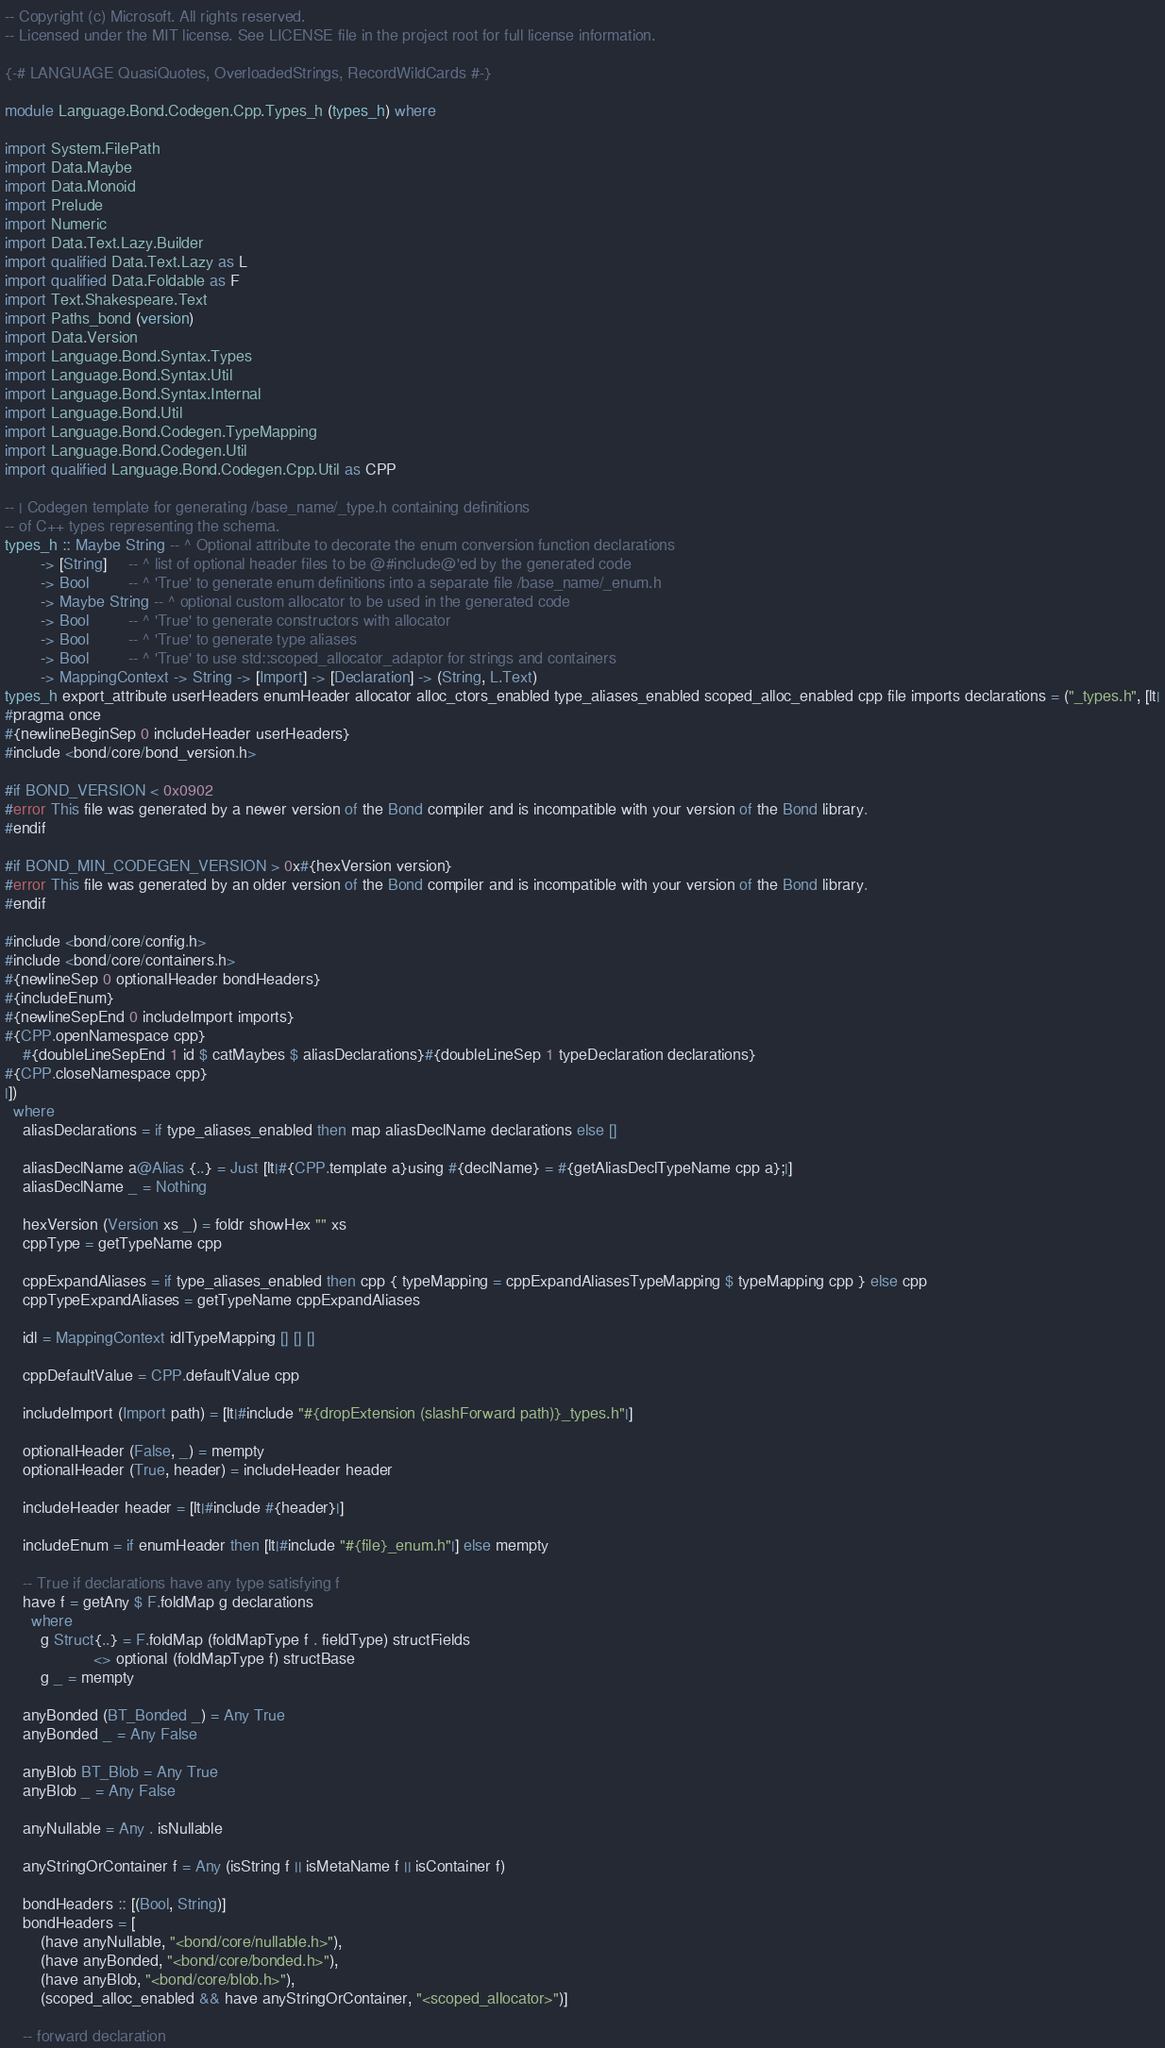Convert code to text. <code><loc_0><loc_0><loc_500><loc_500><_Haskell_>-- Copyright (c) Microsoft. All rights reserved.
-- Licensed under the MIT license. See LICENSE file in the project root for full license information.

{-# LANGUAGE QuasiQuotes, OverloadedStrings, RecordWildCards #-}

module Language.Bond.Codegen.Cpp.Types_h (types_h) where

import System.FilePath
import Data.Maybe
import Data.Monoid
import Prelude
import Numeric
import Data.Text.Lazy.Builder
import qualified Data.Text.Lazy as L
import qualified Data.Foldable as F
import Text.Shakespeare.Text
import Paths_bond (version)
import Data.Version
import Language.Bond.Syntax.Types
import Language.Bond.Syntax.Util
import Language.Bond.Syntax.Internal
import Language.Bond.Util
import Language.Bond.Codegen.TypeMapping
import Language.Bond.Codegen.Util
import qualified Language.Bond.Codegen.Cpp.Util as CPP

-- | Codegen template for generating /base_name/_type.h containing definitions
-- of C++ types representing the schema.
types_h :: Maybe String -- ^ Optional attribute to decorate the enum conversion function declarations
        -> [String]     -- ^ list of optional header files to be @#include@'ed by the generated code
        -> Bool         -- ^ 'True' to generate enum definitions into a separate file /base_name/_enum.h
        -> Maybe String -- ^ optional custom allocator to be used in the generated code
        -> Bool         -- ^ 'True' to generate constructors with allocator
        -> Bool         -- ^ 'True' to generate type aliases
        -> Bool         -- ^ 'True' to use std::scoped_allocator_adaptor for strings and containers
        -> MappingContext -> String -> [Import] -> [Declaration] -> (String, L.Text)
types_h export_attribute userHeaders enumHeader allocator alloc_ctors_enabled type_aliases_enabled scoped_alloc_enabled cpp file imports declarations = ("_types.h", [lt|
#pragma once
#{newlineBeginSep 0 includeHeader userHeaders}
#include <bond/core/bond_version.h>

#if BOND_VERSION < 0x0902
#error This file was generated by a newer version of the Bond compiler and is incompatible with your version of the Bond library.
#endif

#if BOND_MIN_CODEGEN_VERSION > 0x#{hexVersion version}
#error This file was generated by an older version of the Bond compiler and is incompatible with your version of the Bond library.
#endif

#include <bond/core/config.h>
#include <bond/core/containers.h>
#{newlineSep 0 optionalHeader bondHeaders}
#{includeEnum}
#{newlineSepEnd 0 includeImport imports}
#{CPP.openNamespace cpp}
    #{doubleLineSepEnd 1 id $ catMaybes $ aliasDeclarations}#{doubleLineSep 1 typeDeclaration declarations}
#{CPP.closeNamespace cpp}
|])
  where
    aliasDeclarations = if type_aliases_enabled then map aliasDeclName declarations else []

    aliasDeclName a@Alias {..} = Just [lt|#{CPP.template a}using #{declName} = #{getAliasDeclTypeName cpp a};|]
    aliasDeclName _ = Nothing

    hexVersion (Version xs _) = foldr showHex "" xs
    cppType = getTypeName cpp

    cppExpandAliases = if type_aliases_enabled then cpp { typeMapping = cppExpandAliasesTypeMapping $ typeMapping cpp } else cpp
    cppTypeExpandAliases = getTypeName cppExpandAliases

    idl = MappingContext idlTypeMapping [] [] []

    cppDefaultValue = CPP.defaultValue cpp

    includeImport (Import path) = [lt|#include "#{dropExtension (slashForward path)}_types.h"|]

    optionalHeader (False, _) = mempty
    optionalHeader (True, header) = includeHeader header

    includeHeader header = [lt|#include #{header}|]

    includeEnum = if enumHeader then [lt|#include "#{file}_enum.h"|] else mempty

    -- True if declarations have any type satisfying f
    have f = getAny $ F.foldMap g declarations
      where
        g Struct{..} = F.foldMap (foldMapType f . fieldType) structFields
                    <> optional (foldMapType f) structBase
        g _ = mempty

    anyBonded (BT_Bonded _) = Any True
    anyBonded _ = Any False

    anyBlob BT_Blob = Any True
    anyBlob _ = Any False

    anyNullable = Any . isNullable

    anyStringOrContainer f = Any (isString f || isMetaName f || isContainer f)

    bondHeaders :: [(Bool, String)]
    bondHeaders = [
        (have anyNullable, "<bond/core/nullable.h>"),
        (have anyBonded, "<bond/core/bonded.h>"),
        (have anyBlob, "<bond/core/blob.h>"),
        (scoped_alloc_enabled && have anyStringOrContainer, "<scoped_allocator>")]

    -- forward declaration</code> 